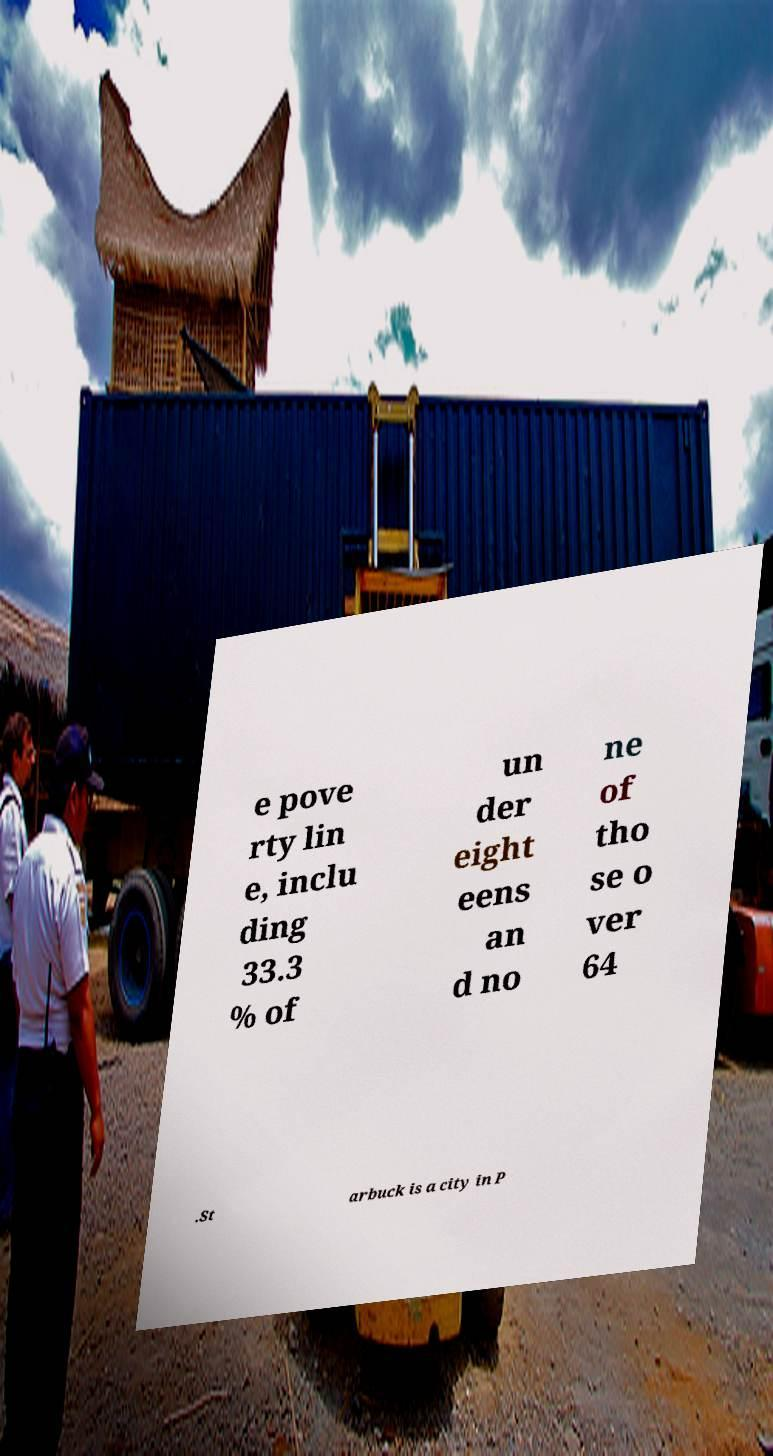Please identify and transcribe the text found in this image. e pove rty lin e, inclu ding 33.3 % of un der eight eens an d no ne of tho se o ver 64 .St arbuck is a city in P 